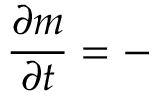Convert formula to latex. <formula><loc_0><loc_0><loc_500><loc_500>{ \frac { \partial m } { \partial t } } = -</formula> 